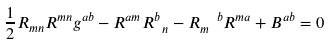Convert formula to latex. <formula><loc_0><loc_0><loc_500><loc_500>\frac { 1 } { 2 } R _ { m n } R ^ { m n } g ^ { a b } - R ^ { a m } R _ { \ n } ^ { b } - R _ { m } ^ { \ \ b } R ^ { m a } + B ^ { a b } = 0</formula> 